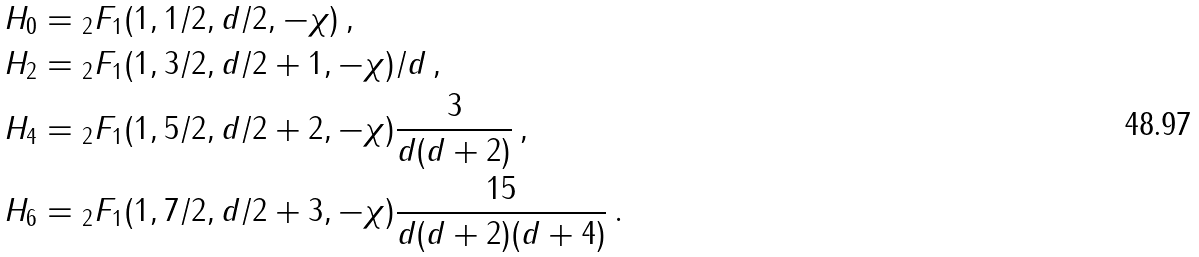<formula> <loc_0><loc_0><loc_500><loc_500>H _ { 0 } & = { _ { 2 } F _ { 1 } } ( 1 , 1 / 2 , d / 2 , - \chi ) \, , \\ H _ { 2 } & = { _ { 2 } F _ { 1 } } ( 1 , 3 / 2 , d / 2 + 1 , - \chi ) / d \, , \\ H _ { 4 } & = { _ { 2 } F _ { 1 } } ( 1 , 5 / 2 , d / 2 + 2 , - \chi ) \frac { 3 } { d ( d + 2 ) } \, , \\ H _ { 6 } & = { _ { 2 } F _ { 1 } } ( 1 , 7 / 2 , d / 2 + 3 , - \chi ) \frac { 1 5 } { d ( d + 2 ) ( d + 4 ) } \, .</formula> 